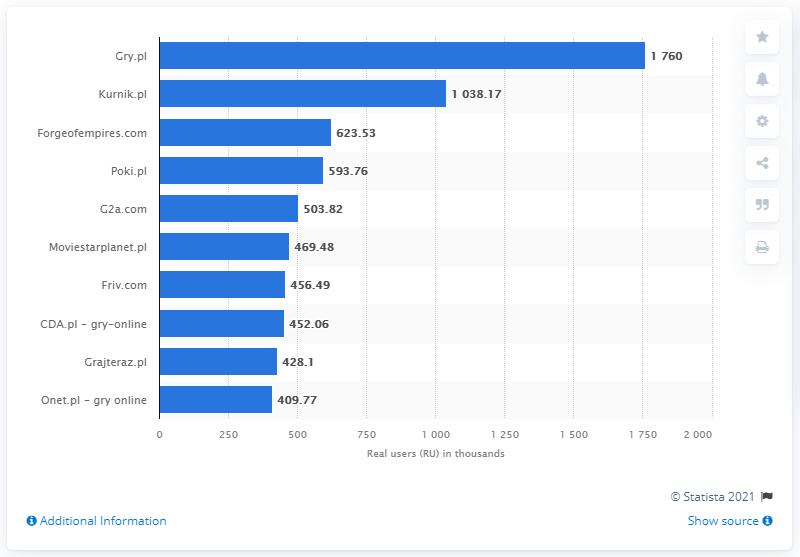What was the leading website for online games in Poland in February 2020? Based on the chart shown in the image, Gry.pl was the leading website for online games in Poland in February 2020, boasting the highest number of real users at approximately 1,760,000. This surpasses the user counts of other popular gaming websites listed. 